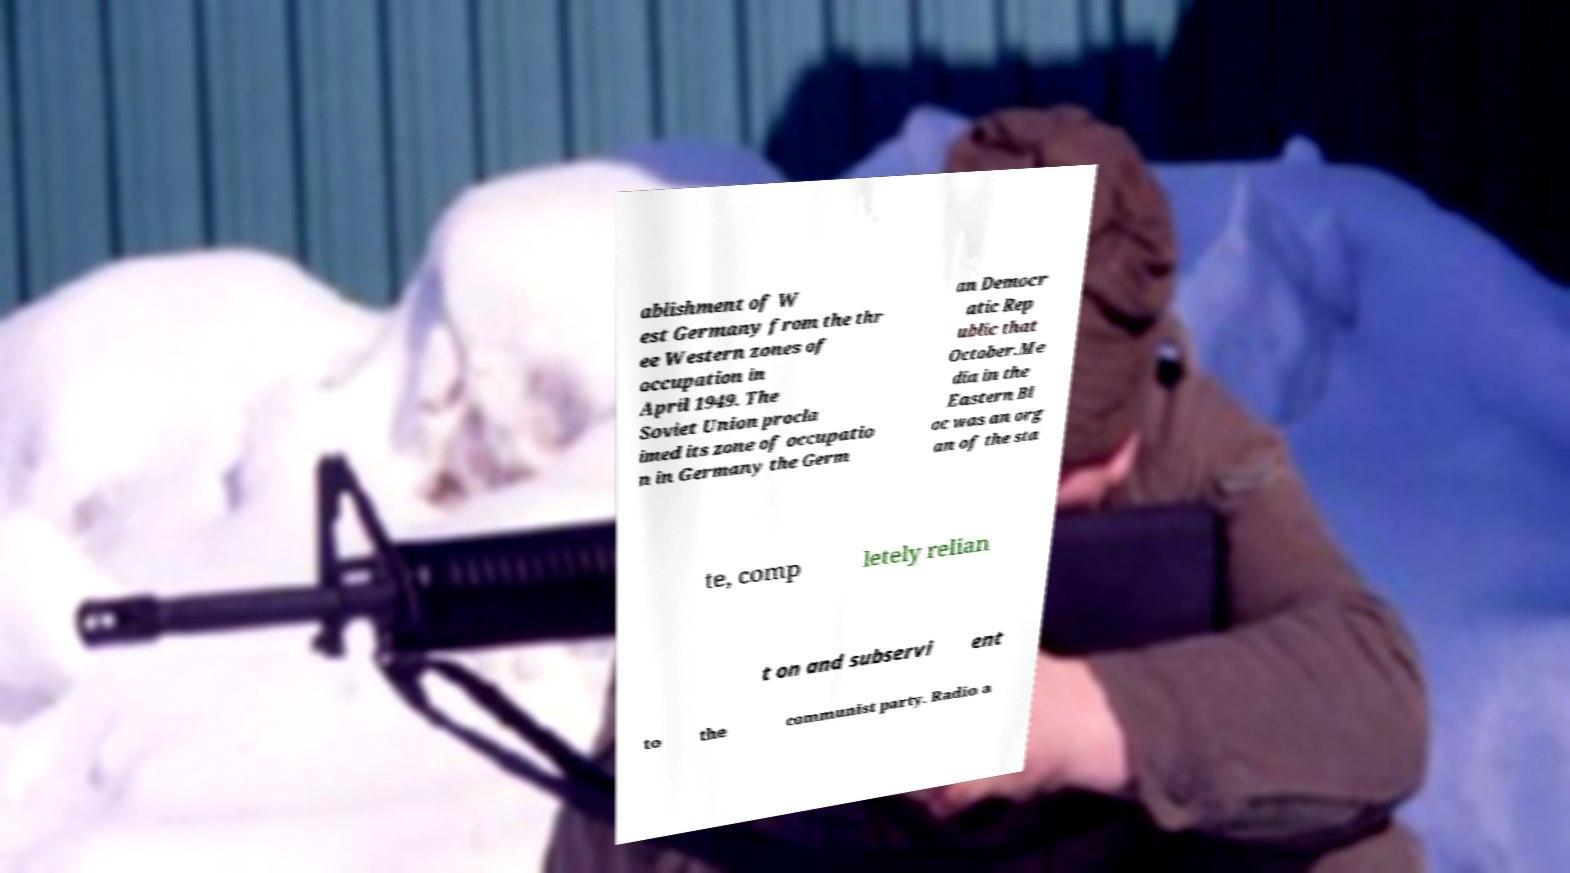There's text embedded in this image that I need extracted. Can you transcribe it verbatim? ablishment of W est Germany from the thr ee Western zones of occupation in April 1949. The Soviet Union procla imed its zone of occupatio n in Germany the Germ an Democr atic Rep ublic that October.Me dia in the Eastern Bl oc was an org an of the sta te, comp letely relian t on and subservi ent to the communist party. Radio a 